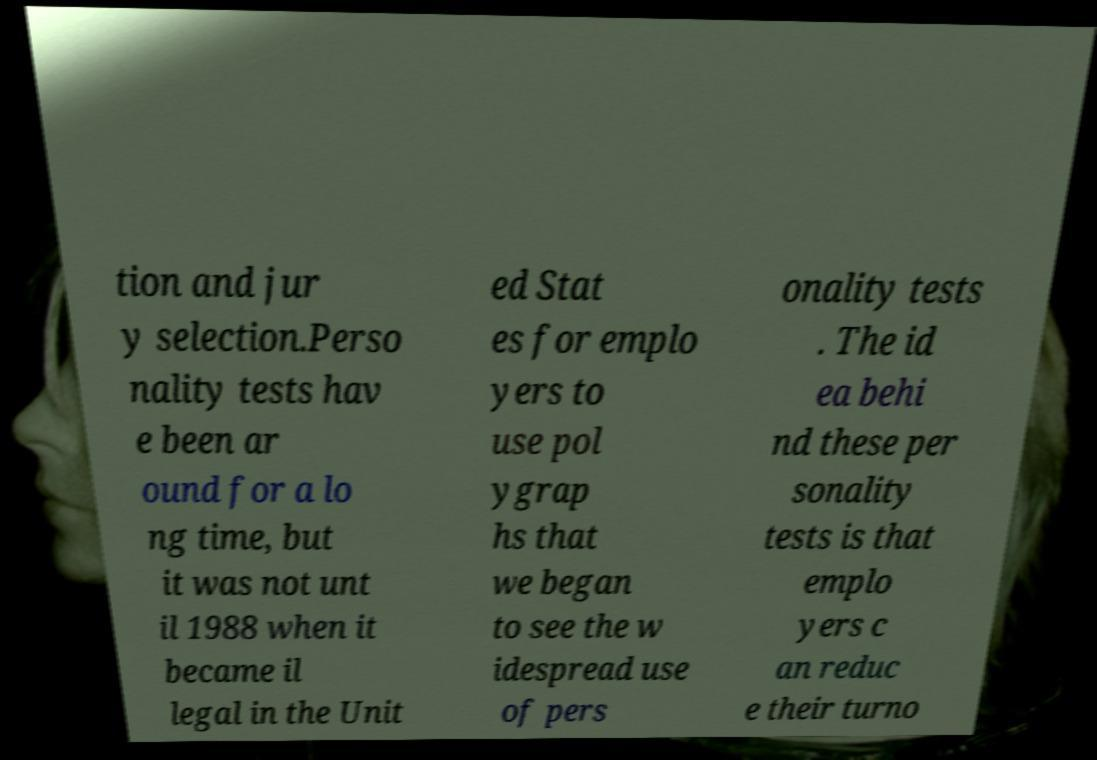Please identify and transcribe the text found in this image. tion and jur y selection.Perso nality tests hav e been ar ound for a lo ng time, but it was not unt il 1988 when it became il legal in the Unit ed Stat es for emplo yers to use pol ygrap hs that we began to see the w idespread use of pers onality tests . The id ea behi nd these per sonality tests is that emplo yers c an reduc e their turno 